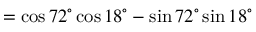<formula> <loc_0><loc_0><loc_500><loc_500>= \cos 7 2 ^ { \circ } \cos 1 8 ^ { \circ } - \sin 7 2 ^ { \circ } \sin 1 8 ^ { \circ }</formula> 